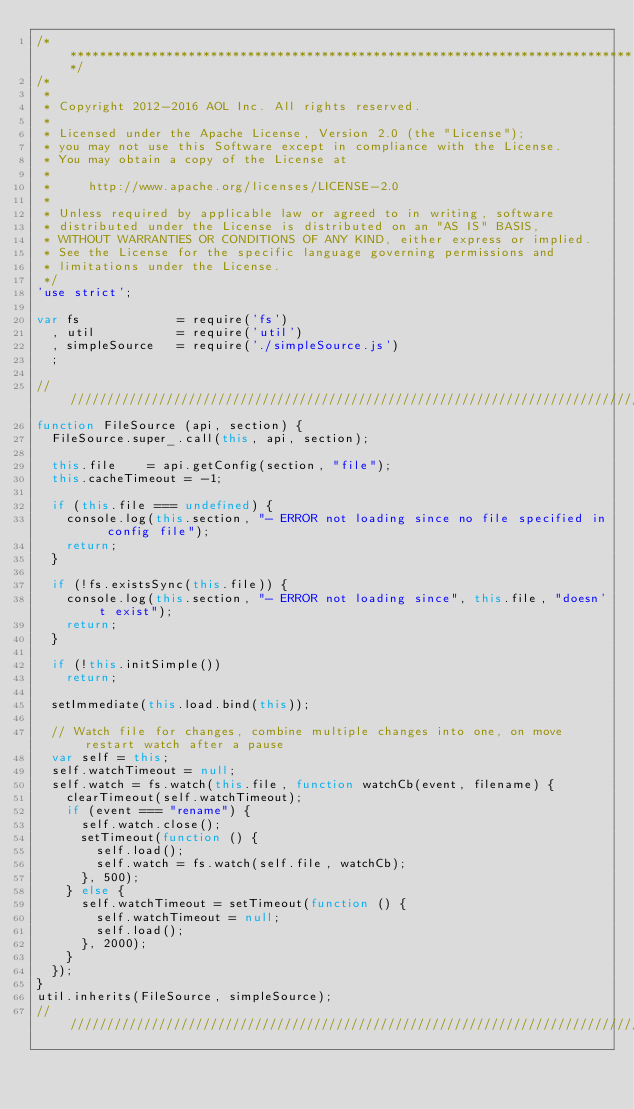<code> <loc_0><loc_0><loc_500><loc_500><_JavaScript_>/******************************************************************************/
/*
 *
 * Copyright 2012-2016 AOL Inc. All rights reserved.
 * 
 * Licensed under the Apache License, Version 2.0 (the "License");
 * you may not use this Software except in compliance with the License.
 * You may obtain a copy of the License at
 * 
 *     http://www.apache.org/licenses/LICENSE-2.0
 * 
 * Unless required by applicable law or agreed to in writing, software
 * distributed under the License is distributed on an "AS IS" BASIS,
 * WITHOUT WARRANTIES OR CONDITIONS OF ANY KIND, either express or implied.
 * See the License for the specific language governing permissions and
 * limitations under the License.
 */
'use strict';

var fs             = require('fs')
  , util           = require('util')
  , simpleSource   = require('./simpleSource.js')
  ;

//////////////////////////////////////////////////////////////////////////////////
function FileSource (api, section) {
  FileSource.super_.call(this, api, section);

  this.file    = api.getConfig(section, "file");
  this.cacheTimeout = -1;

  if (this.file === undefined) {
    console.log(this.section, "- ERROR not loading since no file specified in config file");
    return;
  }

  if (!fs.existsSync(this.file)) {
    console.log(this.section, "- ERROR not loading since", this.file, "doesn't exist");
    return;
  }

  if (!this.initSimple())
    return;

  setImmediate(this.load.bind(this));

  // Watch file for changes, combine multiple changes into one, on move restart watch after a pause
  var self = this;
  self.watchTimeout = null;
  self.watch = fs.watch(this.file, function watchCb(event, filename) {
    clearTimeout(self.watchTimeout);
    if (event === "rename") {
      self.watch.close();
      setTimeout(function () {
        self.load();
        self.watch = fs.watch(self.file, watchCb);
      }, 500);
    } else {
      self.watchTimeout = setTimeout(function () {
        self.watchTimeout = null;
        self.load();
      }, 2000);
    }
  });
}
util.inherits(FileSource, simpleSource);
//////////////////////////////////////////////////////////////////////////////////</code> 